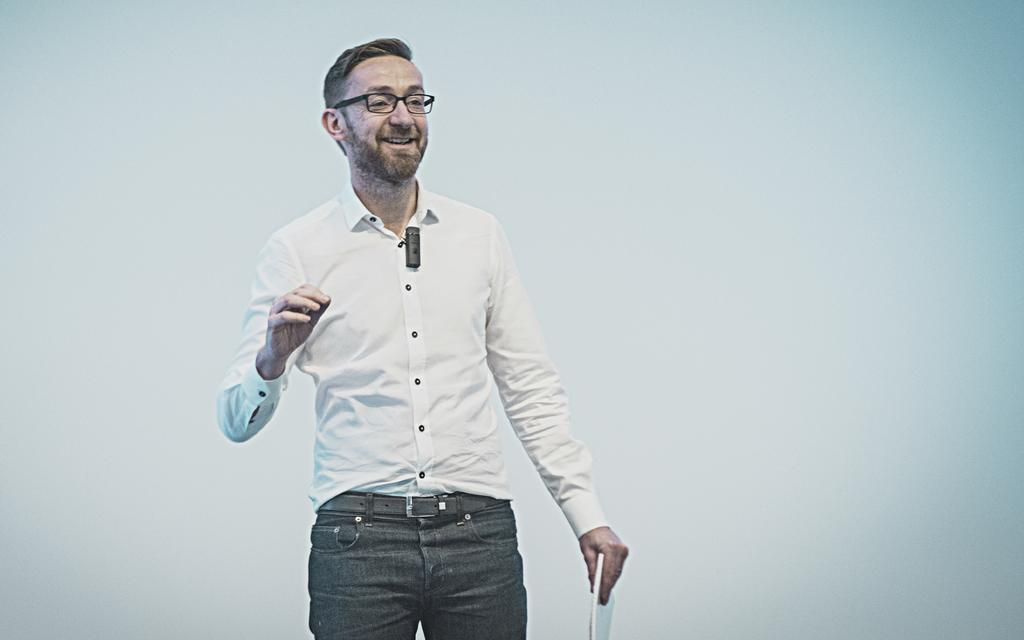Who is the main subject in the image? There is a man in the image. Where is the man located in the image? The man is standing in the foreground area of the image. What is the man holding in his hand? The man is holding a book in his hand. What type of knife is the man using to cut the system in the image? There is no knife or system present in the image; the man is holding a book. 